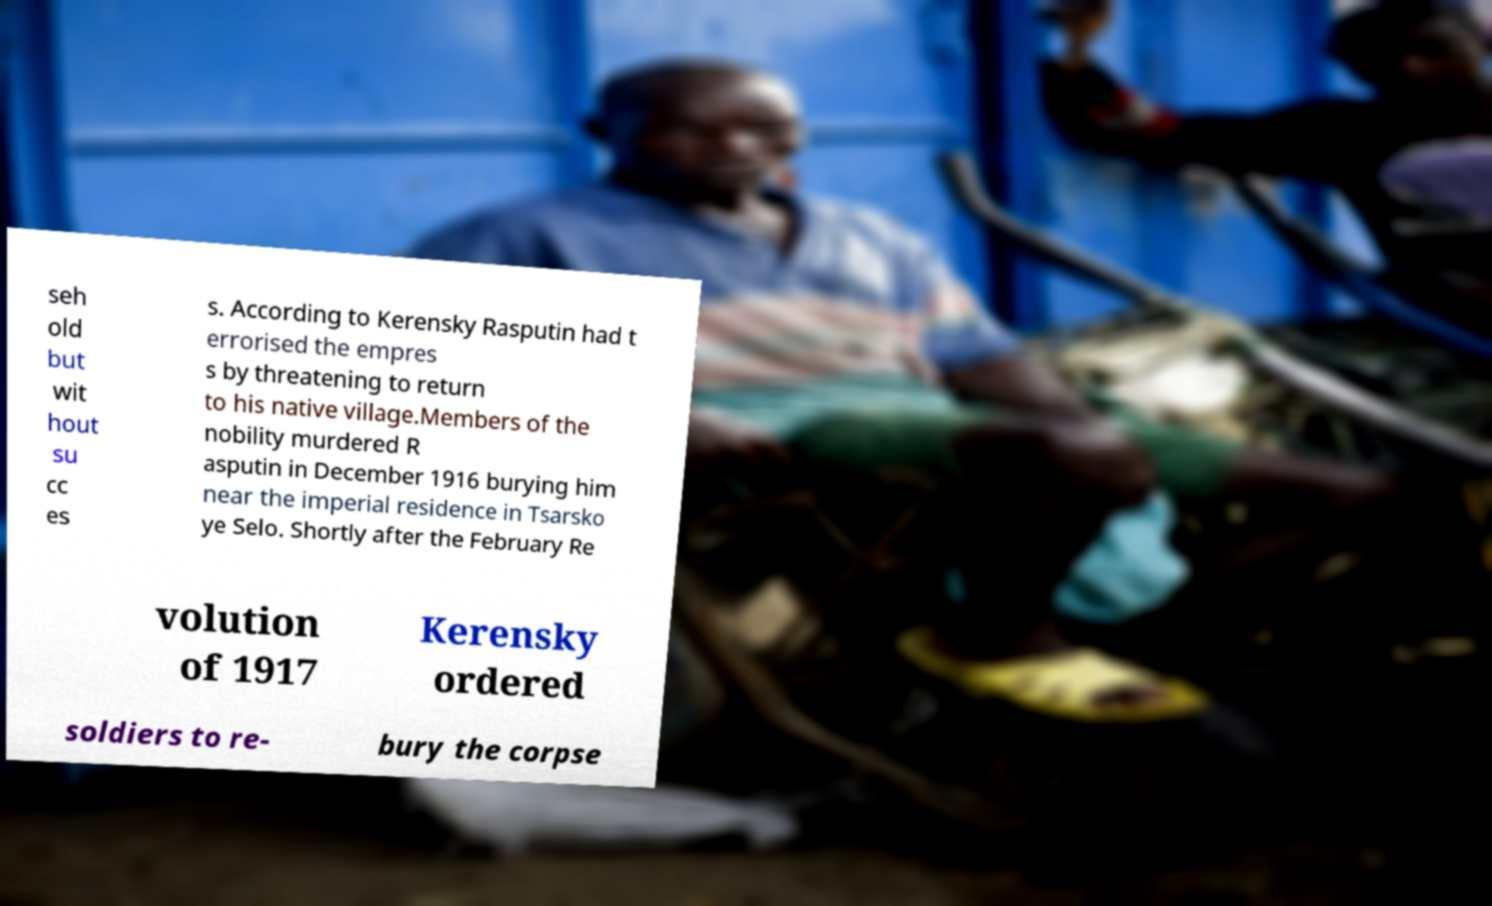Please read and relay the text visible in this image. What does it say? seh old but wit hout su cc es s. According to Kerensky Rasputin had t errorised the empres s by threatening to return to his native village.Members of the nobility murdered R asputin in December 1916 burying him near the imperial residence in Tsarsko ye Selo. Shortly after the February Re volution of 1917 Kerensky ordered soldiers to re- bury the corpse 